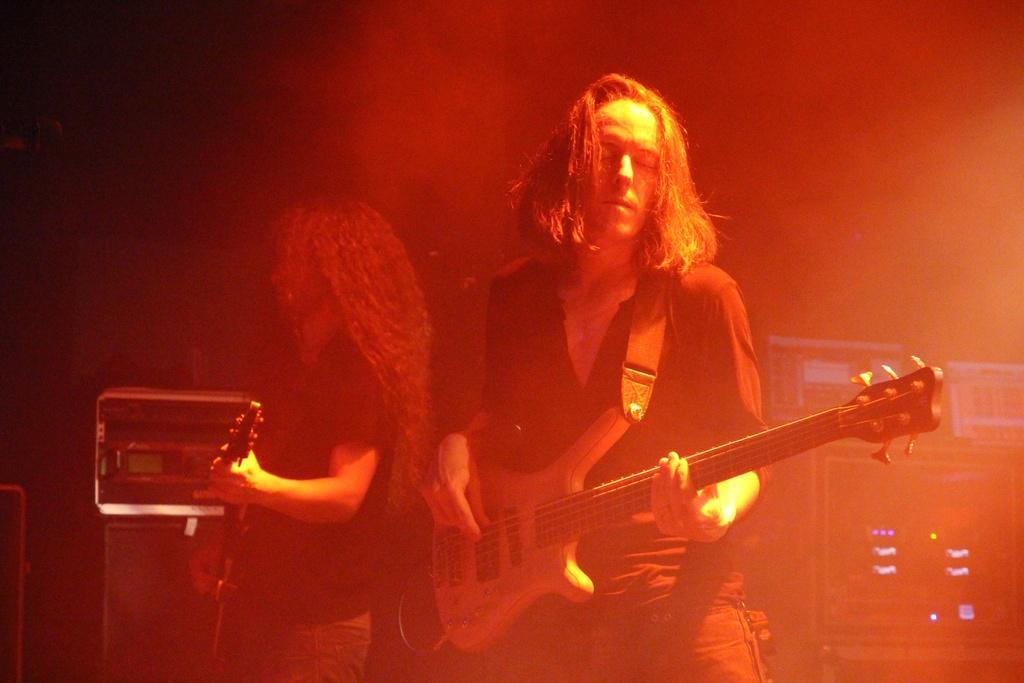Describe this image in one or two sentences. In this image in the foreground there are two persons who are holding some musical instruments, and in the background there are some music systems, lights and some objects. 